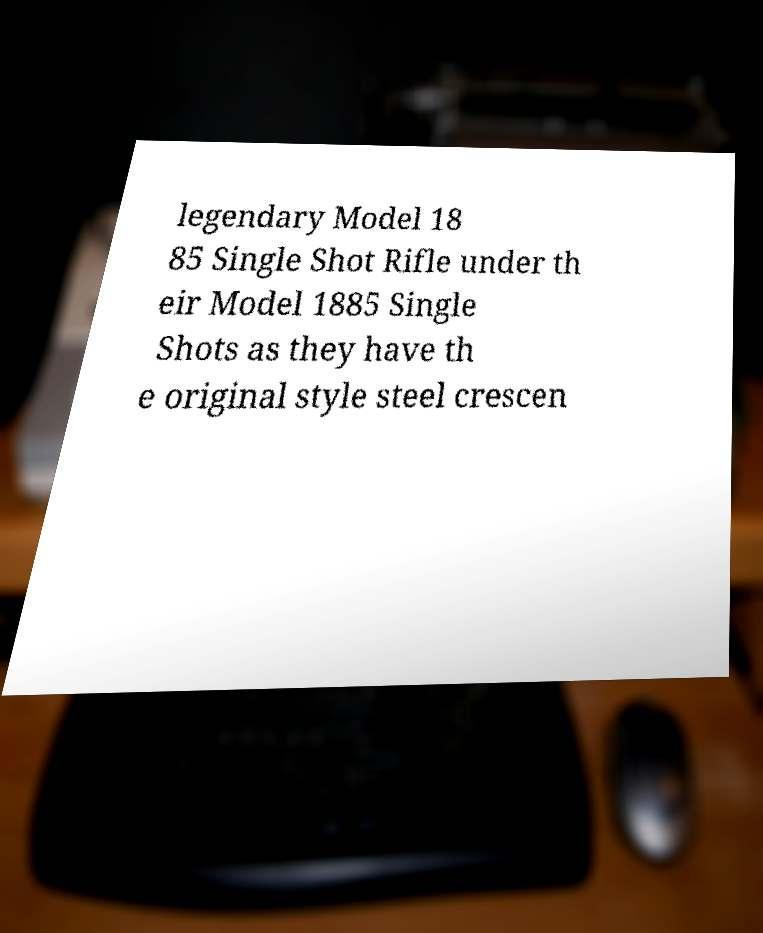There's text embedded in this image that I need extracted. Can you transcribe it verbatim? legendary Model 18 85 Single Shot Rifle under th eir Model 1885 Single Shots as they have th e original style steel crescen 